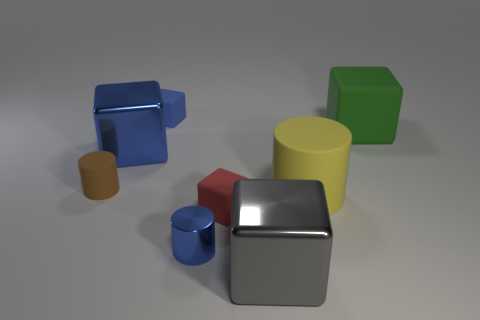Subtract all gray cubes. How many cubes are left? 4 Subtract all tiny blue cubes. How many cubes are left? 4 Subtract 2 blocks. How many blocks are left? 3 Subtract all brown blocks. Subtract all green cylinders. How many blocks are left? 5 Add 1 large gray shiny things. How many objects exist? 9 Subtract all cylinders. How many objects are left? 5 Subtract 0 gray balls. How many objects are left? 8 Subtract all large yellow cubes. Subtract all blue metallic cylinders. How many objects are left? 7 Add 2 red things. How many red things are left? 3 Add 4 blue cylinders. How many blue cylinders exist? 5 